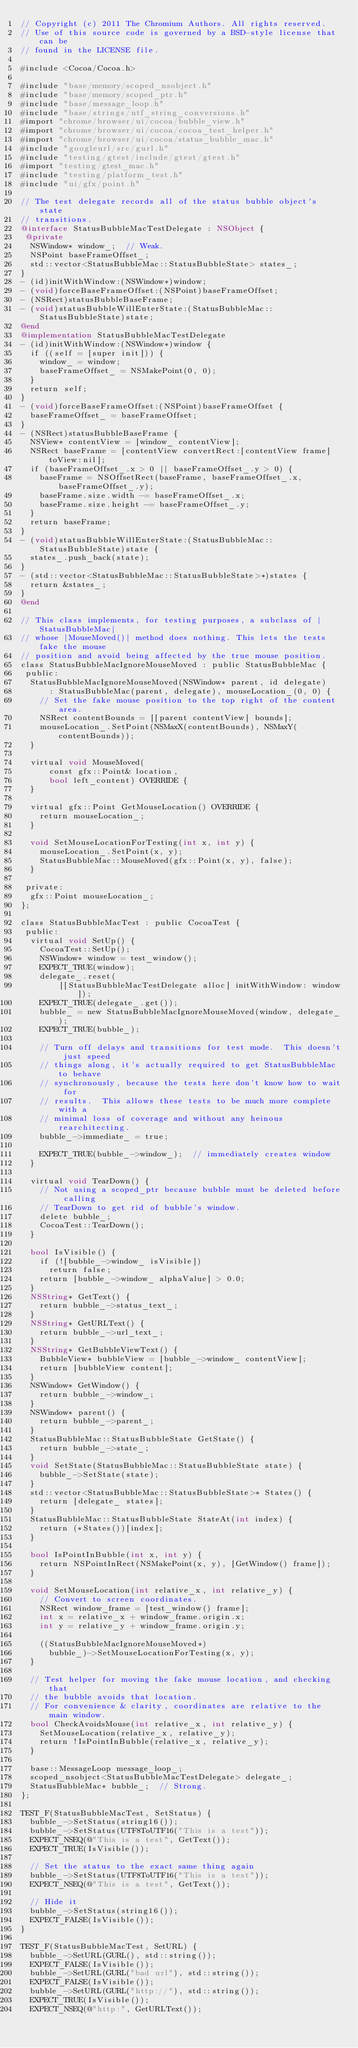<code> <loc_0><loc_0><loc_500><loc_500><_ObjectiveC_>// Copyright (c) 2011 The Chromium Authors. All rights reserved.
// Use of this source code is governed by a BSD-style license that can be
// found in the LICENSE file.

#include <Cocoa/Cocoa.h>

#include "base/memory/scoped_nsobject.h"
#include "base/memory/scoped_ptr.h"
#include "base/message_loop.h"
#include "base/strings/utf_string_conversions.h"
#import "chrome/browser/ui/cocoa/bubble_view.h"
#import "chrome/browser/ui/cocoa/cocoa_test_helper.h"
#import "chrome/browser/ui/cocoa/status_bubble_mac.h"
#include "googleurl/src/gurl.h"
#include "testing/gtest/include/gtest/gtest.h"
#import "testing/gtest_mac.h"
#include "testing/platform_test.h"
#include "ui/gfx/point.h"

// The test delegate records all of the status bubble object's state
// transitions.
@interface StatusBubbleMacTestDelegate : NSObject {
 @private
  NSWindow* window_;  // Weak.
  NSPoint baseFrameOffset_;
  std::vector<StatusBubbleMac::StatusBubbleState> states_;
}
- (id)initWithWindow:(NSWindow*)window;
- (void)forceBaseFrameOffset:(NSPoint)baseFrameOffset;
- (NSRect)statusBubbleBaseFrame;
- (void)statusBubbleWillEnterState:(StatusBubbleMac::StatusBubbleState)state;
@end
@implementation StatusBubbleMacTestDelegate
- (id)initWithWindow:(NSWindow*)window {
  if ((self = [super init])) {
    window_ = window;
    baseFrameOffset_ = NSMakePoint(0, 0);
  }
  return self;
}
- (void)forceBaseFrameOffset:(NSPoint)baseFrameOffset {
  baseFrameOffset_ = baseFrameOffset;
}
- (NSRect)statusBubbleBaseFrame {
  NSView* contentView = [window_ contentView];
  NSRect baseFrame = [contentView convertRect:[contentView frame] toView:nil];
  if (baseFrameOffset_.x > 0 || baseFrameOffset_.y > 0) {
    baseFrame = NSOffsetRect(baseFrame, baseFrameOffset_.x, baseFrameOffset_.y);
    baseFrame.size.width -= baseFrameOffset_.x;
    baseFrame.size.height -= baseFrameOffset_.y;
  }
  return baseFrame;
}
- (void)statusBubbleWillEnterState:(StatusBubbleMac::StatusBubbleState)state {
  states_.push_back(state);
}
- (std::vector<StatusBubbleMac::StatusBubbleState>*)states {
  return &states_;
}
@end

// This class implements, for testing purposes, a subclass of |StatusBubbleMac|
// whose |MouseMoved()| method does nothing. This lets the tests fake the mouse
// position and avoid being affected by the true mouse position.
class StatusBubbleMacIgnoreMouseMoved : public StatusBubbleMac {
 public:
  StatusBubbleMacIgnoreMouseMoved(NSWindow* parent, id delegate)
      : StatusBubbleMac(parent, delegate), mouseLocation_(0, 0) {
    // Set the fake mouse position to the top right of the content area.
    NSRect contentBounds = [[parent contentView] bounds];
    mouseLocation_.SetPoint(NSMaxX(contentBounds), NSMaxY(contentBounds));
  }

  virtual void MouseMoved(
      const gfx::Point& location,
      bool left_content) OVERRIDE {
  }

  virtual gfx::Point GetMouseLocation() OVERRIDE {
    return mouseLocation_;
  }

  void SetMouseLocationForTesting(int x, int y) {
    mouseLocation_.SetPoint(x, y);
    StatusBubbleMac::MouseMoved(gfx::Point(x, y), false);
  }

 private:
  gfx::Point mouseLocation_;
};

class StatusBubbleMacTest : public CocoaTest {
 public:
  virtual void SetUp() {
    CocoaTest::SetUp();
    NSWindow* window = test_window();
    EXPECT_TRUE(window);
    delegate_.reset(
        [[StatusBubbleMacTestDelegate alloc] initWithWindow: window]);
    EXPECT_TRUE(delegate_.get());
    bubble_ = new StatusBubbleMacIgnoreMouseMoved(window, delegate_);
    EXPECT_TRUE(bubble_);

    // Turn off delays and transitions for test mode.  This doesn't just speed
    // things along, it's actually required to get StatusBubbleMac to behave
    // synchronously, because the tests here don't know how to wait for
    // results.  This allows these tests to be much more complete with a
    // minimal loss of coverage and without any heinous rearchitecting.
    bubble_->immediate_ = true;

    EXPECT_TRUE(bubble_->window_);  // immediately creates window
  }

  virtual void TearDown() {
    // Not using a scoped_ptr because bubble must be deleted before calling
    // TearDown to get rid of bubble's window.
    delete bubble_;
    CocoaTest::TearDown();
  }

  bool IsVisible() {
    if (![bubble_->window_ isVisible])
      return false;
    return [bubble_->window_ alphaValue] > 0.0;
  }
  NSString* GetText() {
    return bubble_->status_text_;
  }
  NSString* GetURLText() {
    return bubble_->url_text_;
  }
  NSString* GetBubbleViewText() {
    BubbleView* bubbleView = [bubble_->window_ contentView];
    return [bubbleView content];
  }
  NSWindow* GetWindow() {
    return bubble_->window_;
  }
  NSWindow* parent() {
    return bubble_->parent_;
  }
  StatusBubbleMac::StatusBubbleState GetState() {
    return bubble_->state_;
  }
  void SetState(StatusBubbleMac::StatusBubbleState state) {
    bubble_->SetState(state);
  }
  std::vector<StatusBubbleMac::StatusBubbleState>* States() {
    return [delegate_ states];
  }
  StatusBubbleMac::StatusBubbleState StateAt(int index) {
    return (*States())[index];
  }

  bool IsPointInBubble(int x, int y) {
    return NSPointInRect(NSMakePoint(x, y), [GetWindow() frame]);
  }

  void SetMouseLocation(int relative_x, int relative_y) {
    // Convert to screen coordinates.
    NSRect window_frame = [test_window() frame];
    int x = relative_x + window_frame.origin.x;
    int y = relative_y + window_frame.origin.y;

    ((StatusBubbleMacIgnoreMouseMoved*)
      bubble_)->SetMouseLocationForTesting(x, y);
  }

  // Test helper for moving the fake mouse location, and checking that
  // the bubble avoids that location.
  // For convenience & clarity, coordinates are relative to the main window.
  bool CheckAvoidsMouse(int relative_x, int relative_y) {
    SetMouseLocation(relative_x, relative_y);
    return !IsPointInBubble(relative_x, relative_y);
  }

  base::MessageLoop message_loop_;
  scoped_nsobject<StatusBubbleMacTestDelegate> delegate_;
  StatusBubbleMac* bubble_;  // Strong.
};

TEST_F(StatusBubbleMacTest, SetStatus) {
  bubble_->SetStatus(string16());
  bubble_->SetStatus(UTF8ToUTF16("This is a test"));
  EXPECT_NSEQ(@"This is a test", GetText());
  EXPECT_TRUE(IsVisible());

  // Set the status to the exact same thing again
  bubble_->SetStatus(UTF8ToUTF16("This is a test"));
  EXPECT_NSEQ(@"This is a test", GetText());

  // Hide it
  bubble_->SetStatus(string16());
  EXPECT_FALSE(IsVisible());
}

TEST_F(StatusBubbleMacTest, SetURL) {
  bubble_->SetURL(GURL(), std::string());
  EXPECT_FALSE(IsVisible());
  bubble_->SetURL(GURL("bad url"), std::string());
  EXPECT_FALSE(IsVisible());
  bubble_->SetURL(GURL("http://"), std::string());
  EXPECT_TRUE(IsVisible());
  EXPECT_NSEQ(@"http:", GetURLText());</code> 